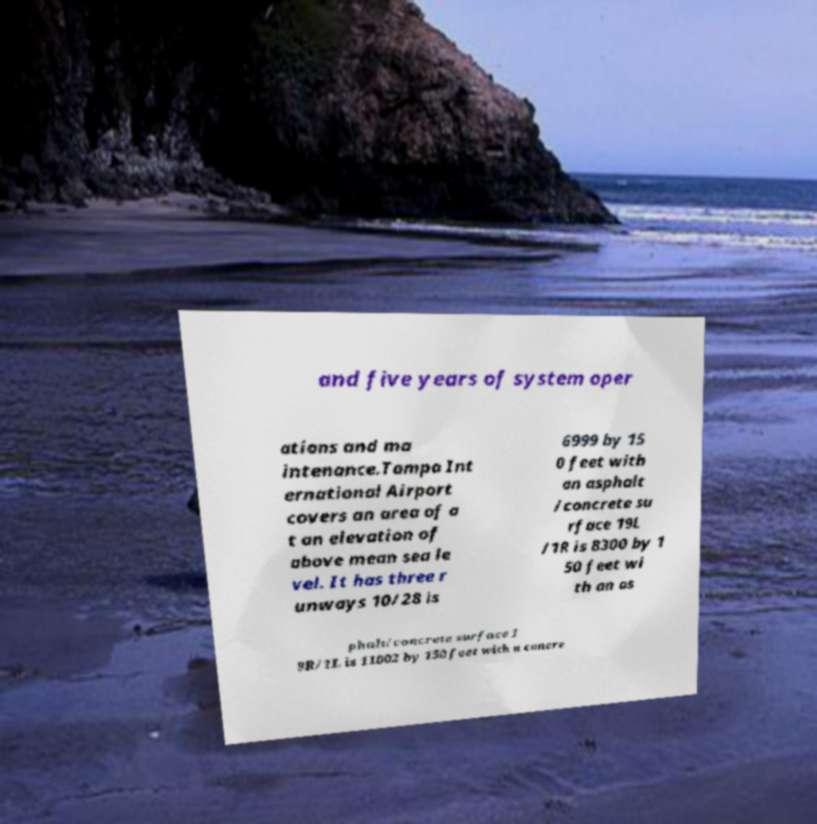Could you assist in decoding the text presented in this image and type it out clearly? and five years of system oper ations and ma intenance.Tampa Int ernational Airport covers an area of a t an elevation of above mean sea le vel. It has three r unways 10/28 is 6999 by 15 0 feet with an asphalt /concrete su rface 19L /1R is 8300 by 1 50 feet wi th an as phalt/concrete surface 1 9R/1L is 11002 by 150 feet with a concre 